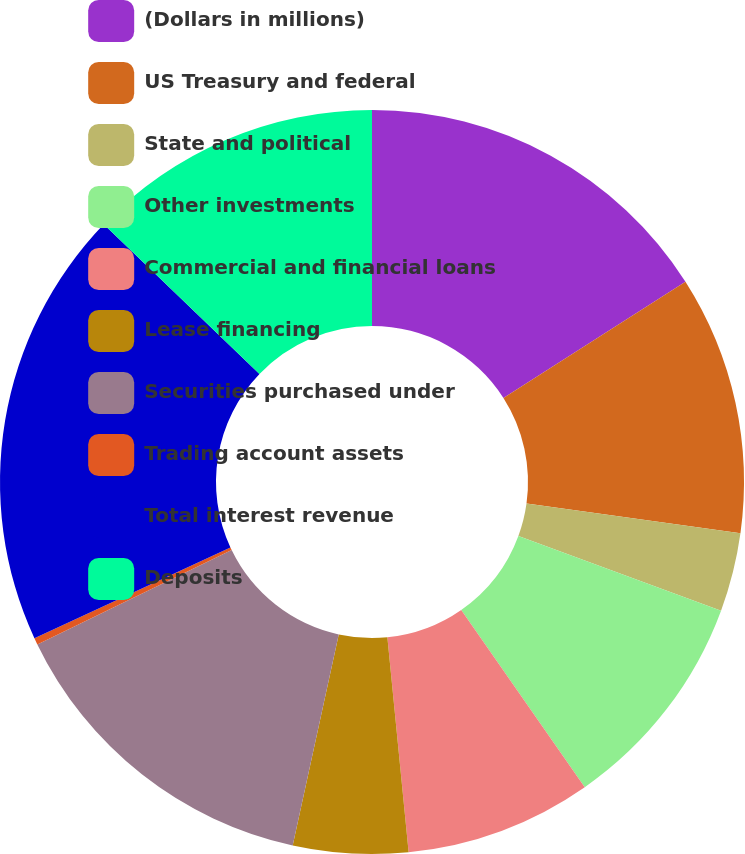<chart> <loc_0><loc_0><loc_500><loc_500><pie_chart><fcel>(Dollars in millions)<fcel>US Treasury and federal<fcel>State and political<fcel>Other investments<fcel>Commercial and financial loans<fcel>Lease financing<fcel>Securities purchased under<fcel>Trading account assets<fcel>Total interest revenue<fcel>Deposits<nl><fcel>15.95%<fcel>11.25%<fcel>3.42%<fcel>9.69%<fcel>8.12%<fcel>4.99%<fcel>14.39%<fcel>0.29%<fcel>19.08%<fcel>12.82%<nl></chart> 